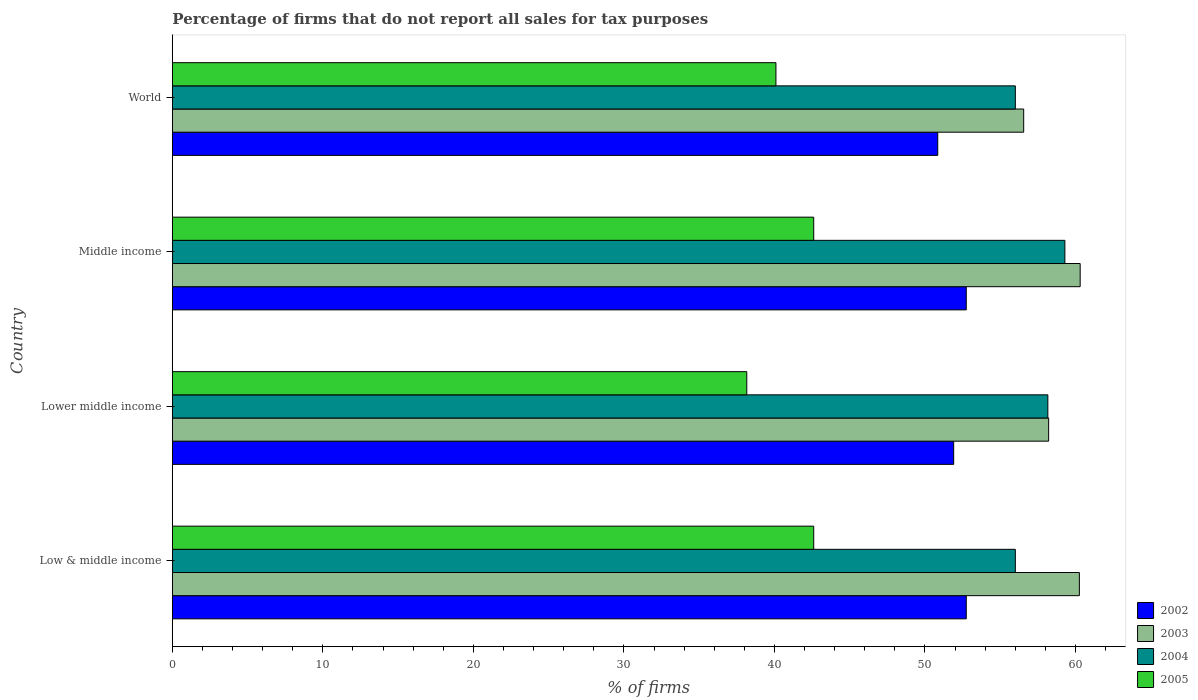How many different coloured bars are there?
Keep it short and to the point. 4. How many bars are there on the 4th tick from the top?
Make the answer very short. 4. How many bars are there on the 2nd tick from the bottom?
Your answer should be very brief. 4. What is the label of the 3rd group of bars from the top?
Your answer should be very brief. Lower middle income. In how many cases, is the number of bars for a given country not equal to the number of legend labels?
Ensure brevity in your answer.  0. What is the percentage of firms that do not report all sales for tax purposes in 2003 in Lower middle income?
Ensure brevity in your answer.  58.22. Across all countries, what is the maximum percentage of firms that do not report all sales for tax purposes in 2005?
Provide a short and direct response. 42.61. Across all countries, what is the minimum percentage of firms that do not report all sales for tax purposes in 2004?
Ensure brevity in your answer.  56.01. In which country was the percentage of firms that do not report all sales for tax purposes in 2005 minimum?
Offer a terse response. Lower middle income. What is the total percentage of firms that do not report all sales for tax purposes in 2005 in the graph?
Provide a succinct answer. 163.48. What is the difference between the percentage of firms that do not report all sales for tax purposes in 2003 in Low & middle income and that in Middle income?
Offer a terse response. -0.05. What is the difference between the percentage of firms that do not report all sales for tax purposes in 2003 in Middle income and the percentage of firms that do not report all sales for tax purposes in 2005 in Low & middle income?
Provide a succinct answer. 17.7. What is the average percentage of firms that do not report all sales for tax purposes in 2004 per country?
Offer a very short reply. 57.37. What is the difference between the percentage of firms that do not report all sales for tax purposes in 2004 and percentage of firms that do not report all sales for tax purposes in 2003 in World?
Your answer should be compact. -0.55. What is the ratio of the percentage of firms that do not report all sales for tax purposes in 2004 in Middle income to that in World?
Your answer should be compact. 1.06. What is the difference between the highest and the second highest percentage of firms that do not report all sales for tax purposes in 2004?
Ensure brevity in your answer.  1.13. What is the difference between the highest and the lowest percentage of firms that do not report all sales for tax purposes in 2002?
Offer a terse response. 1.89. Is the sum of the percentage of firms that do not report all sales for tax purposes in 2002 in Low & middle income and Middle income greater than the maximum percentage of firms that do not report all sales for tax purposes in 2004 across all countries?
Give a very brief answer. Yes. Is it the case that in every country, the sum of the percentage of firms that do not report all sales for tax purposes in 2002 and percentage of firms that do not report all sales for tax purposes in 2003 is greater than the sum of percentage of firms that do not report all sales for tax purposes in 2004 and percentage of firms that do not report all sales for tax purposes in 2005?
Provide a succinct answer. No. What does the 2nd bar from the top in Middle income represents?
Offer a very short reply. 2004. Does the graph contain any zero values?
Provide a succinct answer. No. Does the graph contain grids?
Your answer should be compact. No. What is the title of the graph?
Your answer should be very brief. Percentage of firms that do not report all sales for tax purposes. Does "2014" appear as one of the legend labels in the graph?
Provide a succinct answer. No. What is the label or title of the X-axis?
Offer a very short reply. % of firms. What is the % of firms of 2002 in Low & middle income?
Offer a very short reply. 52.75. What is the % of firms of 2003 in Low & middle income?
Your response must be concise. 60.26. What is the % of firms of 2004 in Low & middle income?
Your answer should be compact. 56.01. What is the % of firms in 2005 in Low & middle income?
Offer a terse response. 42.61. What is the % of firms in 2002 in Lower middle income?
Offer a very short reply. 51.91. What is the % of firms in 2003 in Lower middle income?
Your answer should be very brief. 58.22. What is the % of firms of 2004 in Lower middle income?
Provide a short and direct response. 58.16. What is the % of firms of 2005 in Lower middle income?
Your answer should be very brief. 38.16. What is the % of firms in 2002 in Middle income?
Your response must be concise. 52.75. What is the % of firms in 2003 in Middle income?
Make the answer very short. 60.31. What is the % of firms of 2004 in Middle income?
Offer a very short reply. 59.3. What is the % of firms in 2005 in Middle income?
Give a very brief answer. 42.61. What is the % of firms in 2002 in World?
Keep it short and to the point. 50.85. What is the % of firms of 2003 in World?
Offer a very short reply. 56.56. What is the % of firms of 2004 in World?
Your answer should be very brief. 56.01. What is the % of firms of 2005 in World?
Provide a succinct answer. 40.1. Across all countries, what is the maximum % of firms in 2002?
Your answer should be very brief. 52.75. Across all countries, what is the maximum % of firms in 2003?
Your answer should be compact. 60.31. Across all countries, what is the maximum % of firms in 2004?
Your response must be concise. 59.3. Across all countries, what is the maximum % of firms in 2005?
Your answer should be very brief. 42.61. Across all countries, what is the minimum % of firms of 2002?
Provide a short and direct response. 50.85. Across all countries, what is the minimum % of firms of 2003?
Make the answer very short. 56.56. Across all countries, what is the minimum % of firms of 2004?
Offer a terse response. 56.01. Across all countries, what is the minimum % of firms of 2005?
Make the answer very short. 38.16. What is the total % of firms of 2002 in the graph?
Give a very brief answer. 208.25. What is the total % of firms in 2003 in the graph?
Offer a terse response. 235.35. What is the total % of firms of 2004 in the graph?
Ensure brevity in your answer.  229.47. What is the total % of firms of 2005 in the graph?
Your answer should be compact. 163.48. What is the difference between the % of firms of 2002 in Low & middle income and that in Lower middle income?
Keep it short and to the point. 0.84. What is the difference between the % of firms of 2003 in Low & middle income and that in Lower middle income?
Make the answer very short. 2.04. What is the difference between the % of firms of 2004 in Low & middle income and that in Lower middle income?
Ensure brevity in your answer.  -2.16. What is the difference between the % of firms in 2005 in Low & middle income and that in Lower middle income?
Your response must be concise. 4.45. What is the difference between the % of firms of 2002 in Low & middle income and that in Middle income?
Provide a short and direct response. 0. What is the difference between the % of firms in 2003 in Low & middle income and that in Middle income?
Keep it short and to the point. -0.05. What is the difference between the % of firms in 2004 in Low & middle income and that in Middle income?
Your answer should be very brief. -3.29. What is the difference between the % of firms in 2002 in Low & middle income and that in World?
Keep it short and to the point. 1.89. What is the difference between the % of firms in 2004 in Low & middle income and that in World?
Give a very brief answer. 0. What is the difference between the % of firms in 2005 in Low & middle income and that in World?
Provide a short and direct response. 2.51. What is the difference between the % of firms in 2002 in Lower middle income and that in Middle income?
Offer a terse response. -0.84. What is the difference between the % of firms in 2003 in Lower middle income and that in Middle income?
Offer a very short reply. -2.09. What is the difference between the % of firms of 2004 in Lower middle income and that in Middle income?
Offer a very short reply. -1.13. What is the difference between the % of firms of 2005 in Lower middle income and that in Middle income?
Ensure brevity in your answer.  -4.45. What is the difference between the % of firms of 2002 in Lower middle income and that in World?
Provide a succinct answer. 1.06. What is the difference between the % of firms in 2003 in Lower middle income and that in World?
Offer a terse response. 1.66. What is the difference between the % of firms in 2004 in Lower middle income and that in World?
Make the answer very short. 2.16. What is the difference between the % of firms of 2005 in Lower middle income and that in World?
Your answer should be compact. -1.94. What is the difference between the % of firms in 2002 in Middle income and that in World?
Your answer should be very brief. 1.89. What is the difference between the % of firms in 2003 in Middle income and that in World?
Ensure brevity in your answer.  3.75. What is the difference between the % of firms of 2004 in Middle income and that in World?
Keep it short and to the point. 3.29. What is the difference between the % of firms in 2005 in Middle income and that in World?
Ensure brevity in your answer.  2.51. What is the difference between the % of firms in 2002 in Low & middle income and the % of firms in 2003 in Lower middle income?
Keep it short and to the point. -5.47. What is the difference between the % of firms of 2002 in Low & middle income and the % of firms of 2004 in Lower middle income?
Ensure brevity in your answer.  -5.42. What is the difference between the % of firms in 2002 in Low & middle income and the % of firms in 2005 in Lower middle income?
Give a very brief answer. 14.58. What is the difference between the % of firms in 2003 in Low & middle income and the % of firms in 2004 in Lower middle income?
Provide a succinct answer. 2.1. What is the difference between the % of firms of 2003 in Low & middle income and the % of firms of 2005 in Lower middle income?
Your answer should be very brief. 22.1. What is the difference between the % of firms of 2004 in Low & middle income and the % of firms of 2005 in Lower middle income?
Provide a succinct answer. 17.84. What is the difference between the % of firms of 2002 in Low & middle income and the % of firms of 2003 in Middle income?
Your answer should be very brief. -7.57. What is the difference between the % of firms in 2002 in Low & middle income and the % of firms in 2004 in Middle income?
Your answer should be compact. -6.55. What is the difference between the % of firms of 2002 in Low & middle income and the % of firms of 2005 in Middle income?
Ensure brevity in your answer.  10.13. What is the difference between the % of firms of 2003 in Low & middle income and the % of firms of 2004 in Middle income?
Provide a succinct answer. 0.96. What is the difference between the % of firms in 2003 in Low & middle income and the % of firms in 2005 in Middle income?
Keep it short and to the point. 17.65. What is the difference between the % of firms of 2004 in Low & middle income and the % of firms of 2005 in Middle income?
Your answer should be compact. 13.39. What is the difference between the % of firms in 2002 in Low & middle income and the % of firms in 2003 in World?
Your response must be concise. -3.81. What is the difference between the % of firms in 2002 in Low & middle income and the % of firms in 2004 in World?
Provide a succinct answer. -3.26. What is the difference between the % of firms in 2002 in Low & middle income and the % of firms in 2005 in World?
Keep it short and to the point. 12.65. What is the difference between the % of firms in 2003 in Low & middle income and the % of firms in 2004 in World?
Provide a succinct answer. 4.25. What is the difference between the % of firms of 2003 in Low & middle income and the % of firms of 2005 in World?
Make the answer very short. 20.16. What is the difference between the % of firms of 2004 in Low & middle income and the % of firms of 2005 in World?
Give a very brief answer. 15.91. What is the difference between the % of firms in 2002 in Lower middle income and the % of firms in 2003 in Middle income?
Give a very brief answer. -8.4. What is the difference between the % of firms in 2002 in Lower middle income and the % of firms in 2004 in Middle income?
Your answer should be very brief. -7.39. What is the difference between the % of firms in 2002 in Lower middle income and the % of firms in 2005 in Middle income?
Offer a very short reply. 9.3. What is the difference between the % of firms in 2003 in Lower middle income and the % of firms in 2004 in Middle income?
Ensure brevity in your answer.  -1.08. What is the difference between the % of firms of 2003 in Lower middle income and the % of firms of 2005 in Middle income?
Ensure brevity in your answer.  15.61. What is the difference between the % of firms in 2004 in Lower middle income and the % of firms in 2005 in Middle income?
Make the answer very short. 15.55. What is the difference between the % of firms of 2002 in Lower middle income and the % of firms of 2003 in World?
Provide a short and direct response. -4.65. What is the difference between the % of firms in 2002 in Lower middle income and the % of firms in 2004 in World?
Provide a succinct answer. -4.1. What is the difference between the % of firms of 2002 in Lower middle income and the % of firms of 2005 in World?
Your answer should be very brief. 11.81. What is the difference between the % of firms of 2003 in Lower middle income and the % of firms of 2004 in World?
Keep it short and to the point. 2.21. What is the difference between the % of firms of 2003 in Lower middle income and the % of firms of 2005 in World?
Ensure brevity in your answer.  18.12. What is the difference between the % of firms in 2004 in Lower middle income and the % of firms in 2005 in World?
Make the answer very short. 18.07. What is the difference between the % of firms in 2002 in Middle income and the % of firms in 2003 in World?
Keep it short and to the point. -3.81. What is the difference between the % of firms of 2002 in Middle income and the % of firms of 2004 in World?
Offer a very short reply. -3.26. What is the difference between the % of firms of 2002 in Middle income and the % of firms of 2005 in World?
Make the answer very short. 12.65. What is the difference between the % of firms of 2003 in Middle income and the % of firms of 2004 in World?
Make the answer very short. 4.31. What is the difference between the % of firms in 2003 in Middle income and the % of firms in 2005 in World?
Make the answer very short. 20.21. What is the difference between the % of firms in 2004 in Middle income and the % of firms in 2005 in World?
Make the answer very short. 19.2. What is the average % of firms of 2002 per country?
Keep it short and to the point. 52.06. What is the average % of firms of 2003 per country?
Your answer should be very brief. 58.84. What is the average % of firms of 2004 per country?
Offer a very short reply. 57.37. What is the average % of firms in 2005 per country?
Give a very brief answer. 40.87. What is the difference between the % of firms in 2002 and % of firms in 2003 in Low & middle income?
Make the answer very short. -7.51. What is the difference between the % of firms in 2002 and % of firms in 2004 in Low & middle income?
Provide a short and direct response. -3.26. What is the difference between the % of firms in 2002 and % of firms in 2005 in Low & middle income?
Your response must be concise. 10.13. What is the difference between the % of firms of 2003 and % of firms of 2004 in Low & middle income?
Your response must be concise. 4.25. What is the difference between the % of firms in 2003 and % of firms in 2005 in Low & middle income?
Ensure brevity in your answer.  17.65. What is the difference between the % of firms in 2004 and % of firms in 2005 in Low & middle income?
Make the answer very short. 13.39. What is the difference between the % of firms in 2002 and % of firms in 2003 in Lower middle income?
Ensure brevity in your answer.  -6.31. What is the difference between the % of firms in 2002 and % of firms in 2004 in Lower middle income?
Offer a terse response. -6.26. What is the difference between the % of firms of 2002 and % of firms of 2005 in Lower middle income?
Provide a succinct answer. 13.75. What is the difference between the % of firms in 2003 and % of firms in 2004 in Lower middle income?
Keep it short and to the point. 0.05. What is the difference between the % of firms of 2003 and % of firms of 2005 in Lower middle income?
Provide a short and direct response. 20.06. What is the difference between the % of firms in 2004 and % of firms in 2005 in Lower middle income?
Make the answer very short. 20. What is the difference between the % of firms of 2002 and % of firms of 2003 in Middle income?
Offer a terse response. -7.57. What is the difference between the % of firms of 2002 and % of firms of 2004 in Middle income?
Provide a short and direct response. -6.55. What is the difference between the % of firms of 2002 and % of firms of 2005 in Middle income?
Your answer should be compact. 10.13. What is the difference between the % of firms of 2003 and % of firms of 2004 in Middle income?
Your answer should be compact. 1.02. What is the difference between the % of firms in 2003 and % of firms in 2005 in Middle income?
Keep it short and to the point. 17.7. What is the difference between the % of firms in 2004 and % of firms in 2005 in Middle income?
Your answer should be very brief. 16.69. What is the difference between the % of firms in 2002 and % of firms in 2003 in World?
Keep it short and to the point. -5.71. What is the difference between the % of firms of 2002 and % of firms of 2004 in World?
Make the answer very short. -5.15. What is the difference between the % of firms of 2002 and % of firms of 2005 in World?
Ensure brevity in your answer.  10.75. What is the difference between the % of firms in 2003 and % of firms in 2004 in World?
Your answer should be compact. 0.56. What is the difference between the % of firms of 2003 and % of firms of 2005 in World?
Your answer should be very brief. 16.46. What is the difference between the % of firms in 2004 and % of firms in 2005 in World?
Make the answer very short. 15.91. What is the ratio of the % of firms in 2002 in Low & middle income to that in Lower middle income?
Your answer should be compact. 1.02. What is the ratio of the % of firms in 2003 in Low & middle income to that in Lower middle income?
Your answer should be very brief. 1.04. What is the ratio of the % of firms of 2004 in Low & middle income to that in Lower middle income?
Make the answer very short. 0.96. What is the ratio of the % of firms of 2005 in Low & middle income to that in Lower middle income?
Provide a succinct answer. 1.12. What is the ratio of the % of firms of 2002 in Low & middle income to that in Middle income?
Ensure brevity in your answer.  1. What is the ratio of the % of firms in 2003 in Low & middle income to that in Middle income?
Keep it short and to the point. 1. What is the ratio of the % of firms in 2004 in Low & middle income to that in Middle income?
Make the answer very short. 0.94. What is the ratio of the % of firms in 2005 in Low & middle income to that in Middle income?
Ensure brevity in your answer.  1. What is the ratio of the % of firms in 2002 in Low & middle income to that in World?
Give a very brief answer. 1.04. What is the ratio of the % of firms in 2003 in Low & middle income to that in World?
Ensure brevity in your answer.  1.07. What is the ratio of the % of firms of 2005 in Low & middle income to that in World?
Your answer should be compact. 1.06. What is the ratio of the % of firms of 2002 in Lower middle income to that in Middle income?
Give a very brief answer. 0.98. What is the ratio of the % of firms in 2003 in Lower middle income to that in Middle income?
Offer a very short reply. 0.97. What is the ratio of the % of firms in 2004 in Lower middle income to that in Middle income?
Offer a terse response. 0.98. What is the ratio of the % of firms in 2005 in Lower middle income to that in Middle income?
Ensure brevity in your answer.  0.9. What is the ratio of the % of firms of 2002 in Lower middle income to that in World?
Provide a succinct answer. 1.02. What is the ratio of the % of firms of 2003 in Lower middle income to that in World?
Offer a very short reply. 1.03. What is the ratio of the % of firms of 2004 in Lower middle income to that in World?
Your answer should be compact. 1.04. What is the ratio of the % of firms in 2005 in Lower middle income to that in World?
Provide a succinct answer. 0.95. What is the ratio of the % of firms of 2002 in Middle income to that in World?
Your answer should be very brief. 1.04. What is the ratio of the % of firms in 2003 in Middle income to that in World?
Provide a succinct answer. 1.07. What is the ratio of the % of firms of 2004 in Middle income to that in World?
Your answer should be compact. 1.06. What is the ratio of the % of firms in 2005 in Middle income to that in World?
Make the answer very short. 1.06. What is the difference between the highest and the second highest % of firms in 2003?
Provide a short and direct response. 0.05. What is the difference between the highest and the second highest % of firms in 2004?
Your answer should be very brief. 1.13. What is the difference between the highest and the lowest % of firms of 2002?
Ensure brevity in your answer.  1.89. What is the difference between the highest and the lowest % of firms of 2003?
Keep it short and to the point. 3.75. What is the difference between the highest and the lowest % of firms of 2004?
Ensure brevity in your answer.  3.29. What is the difference between the highest and the lowest % of firms in 2005?
Your response must be concise. 4.45. 